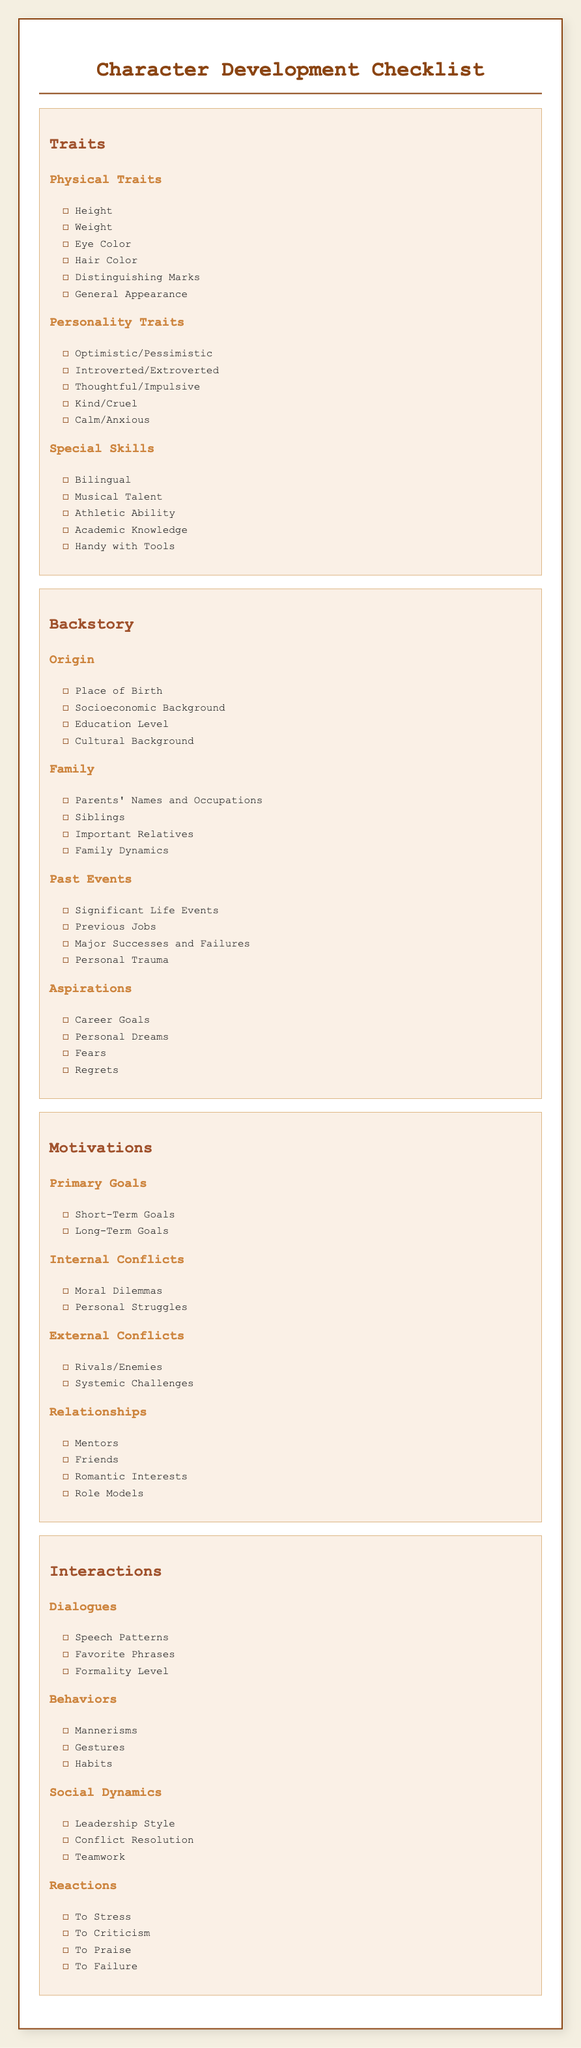What are the personality traits listed? The document lists personality traits under the "Personality Traits" section in "Traits."
Answer: Optimistic/Pessimistic, Introverted/Extroverted, Thoughtful/Impulsive, Kind/Cruel, Calm/Anxious What is included in "Physical Traits"? The "Physical Traits" section includes details about the character’s appearance.
Answer: Height, Weight, Eye Color, Hair Color, Distinguishing Marks, General Appearance What are the primary goals mentioned? The primary goals are detailed in the "Primary Goals" section under "Motivations."
Answer: Short-Term Goals, Long-Term Goals Name a type of relationship listed under "Relationships." The "Relationships" section includes various types of relationships the character may have.
Answer: Mentors, Friends, Romantic Interests, Role Models What does the "Internal Conflicts" section refer to? The "Internal Conflicts" section focuses on the personal struggles faced by the character.
Answer: Moral Dilemmas, Personal Struggles How many subsections are under "Backstory"? Counting the subsections in the "Backstory" section gives the number of distinct areas covered.
Answer: Four What are two components of "Dialogues"? The "Dialogues" section includes specific characteristics related to how the character communicates.
Answer: Speech Patterns, Favorite Phrases How many types of traits are specified in the document? The document classifies traits into different categories; counting them provides the total number.
Answer: Three What kind of skills are mentioned under "Special Skills"? The "Special Skills" section includes particular abilities that a character may possess.
Answer: Bilingual, Musical Talent, Athletic Ability, Academic Knowledge, Handy with Tools 